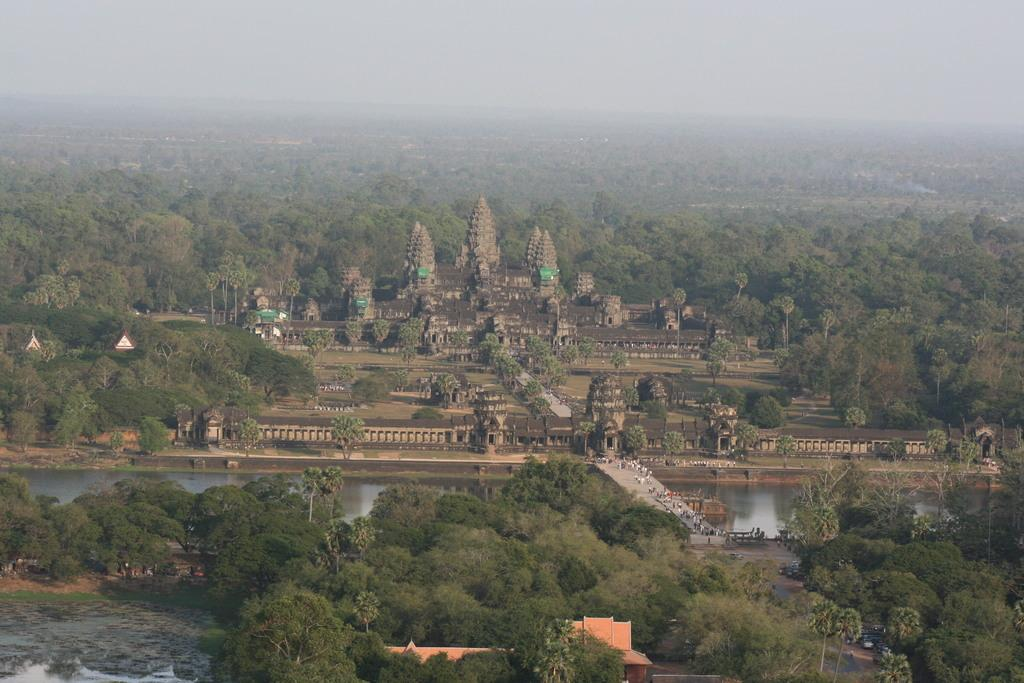What is the main structure in the center of the image? There is a fort in the center of the image. What can be seen at the bottom of the image? Trees, persons, and water are visible at the bottom of the image. Are there any natural elements in the background of the image? Yes, there are trees in the background of the image. What is visible in the sky in the background of the image? The sky is visible in the background of the image. Can you describe the coil that is present in the image? There is no coil present in the image. How many cattle can be seen grazing near the fort in the image? There are no cattle present in the image. 